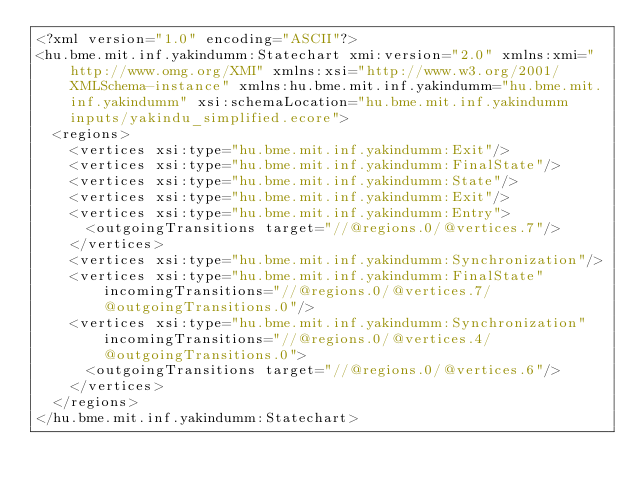Convert code to text. <code><loc_0><loc_0><loc_500><loc_500><_XML_><?xml version="1.0" encoding="ASCII"?>
<hu.bme.mit.inf.yakindumm:Statechart xmi:version="2.0" xmlns:xmi="http://www.omg.org/XMI" xmlns:xsi="http://www.w3.org/2001/XMLSchema-instance" xmlns:hu.bme.mit.inf.yakindumm="hu.bme.mit.inf.yakindumm" xsi:schemaLocation="hu.bme.mit.inf.yakindumm inputs/yakindu_simplified.ecore">
  <regions>
    <vertices xsi:type="hu.bme.mit.inf.yakindumm:Exit"/>
    <vertices xsi:type="hu.bme.mit.inf.yakindumm:FinalState"/>
    <vertices xsi:type="hu.bme.mit.inf.yakindumm:State"/>
    <vertices xsi:type="hu.bme.mit.inf.yakindumm:Exit"/>
    <vertices xsi:type="hu.bme.mit.inf.yakindumm:Entry">
      <outgoingTransitions target="//@regions.0/@vertices.7"/>
    </vertices>
    <vertices xsi:type="hu.bme.mit.inf.yakindumm:Synchronization"/>
    <vertices xsi:type="hu.bme.mit.inf.yakindumm:FinalState" incomingTransitions="//@regions.0/@vertices.7/@outgoingTransitions.0"/>
    <vertices xsi:type="hu.bme.mit.inf.yakindumm:Synchronization" incomingTransitions="//@regions.0/@vertices.4/@outgoingTransitions.0">
      <outgoingTransitions target="//@regions.0/@vertices.6"/>
    </vertices>
  </regions>
</hu.bme.mit.inf.yakindumm:Statechart>
</code> 